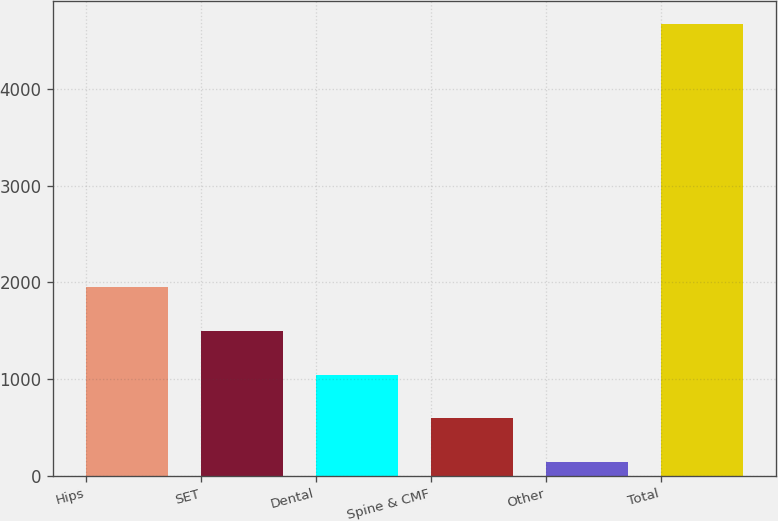<chart> <loc_0><loc_0><loc_500><loc_500><bar_chart><fcel>Hips<fcel>SET<fcel>Dental<fcel>Spine & CMF<fcel>Other<fcel>Total<nl><fcel>1952.42<fcel>1498.94<fcel>1045.46<fcel>591.98<fcel>138.5<fcel>4673.3<nl></chart> 